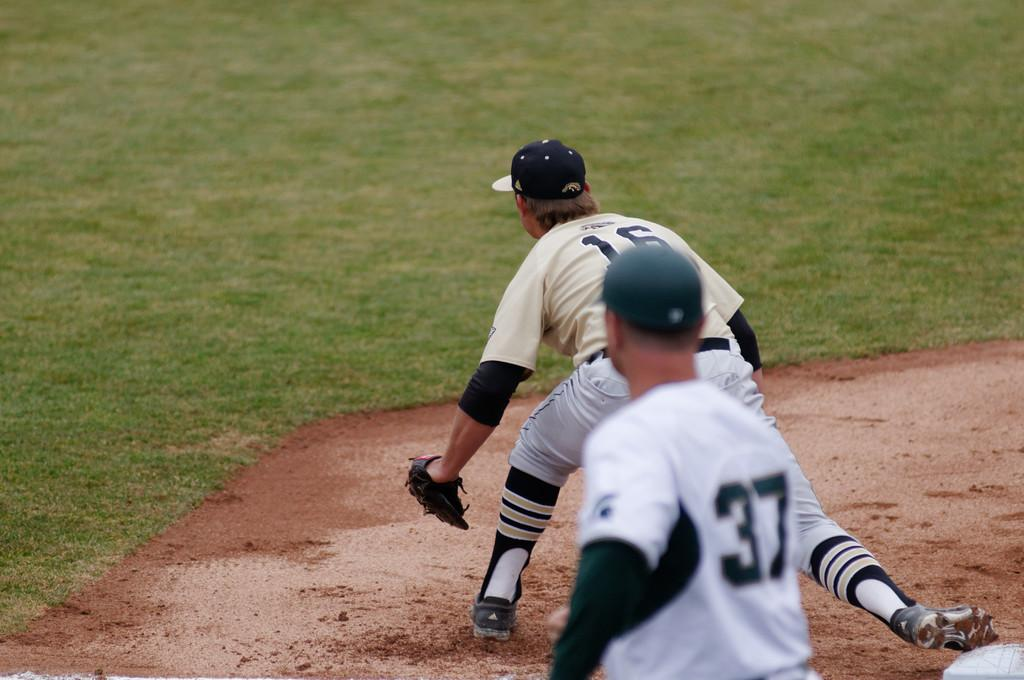<image>
Create a compact narrative representing the image presented. Number 37 stands behind the player trying to catch the ball. 